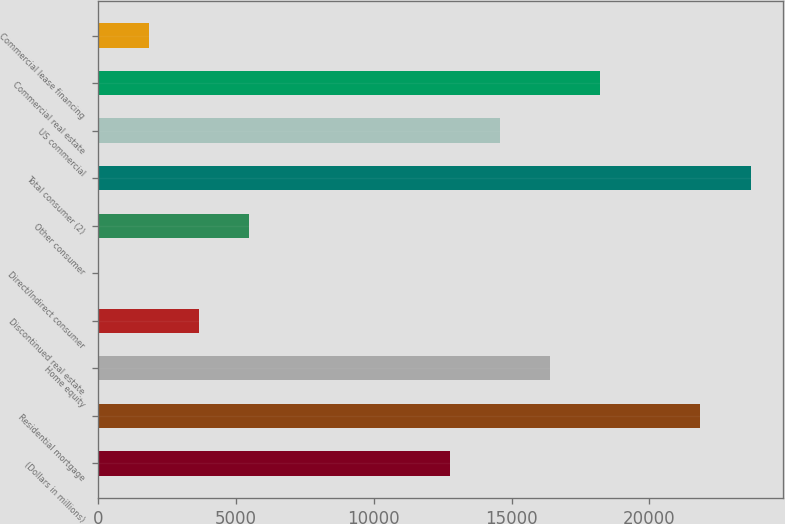<chart> <loc_0><loc_0><loc_500><loc_500><bar_chart><fcel>(Dollars in millions)<fcel>Residential mortgage<fcel>Home equity<fcel>Discontinued real estate<fcel>Direct/Indirect consumer<fcel>Other consumer<fcel>Total consumer (2)<fcel>US commercial<fcel>Commercial real estate<fcel>Commercial lease financing<nl><fcel>12756.2<fcel>21849.2<fcel>16393.4<fcel>3663.2<fcel>26<fcel>5481.8<fcel>23667.8<fcel>14574.8<fcel>18212<fcel>1844.6<nl></chart> 